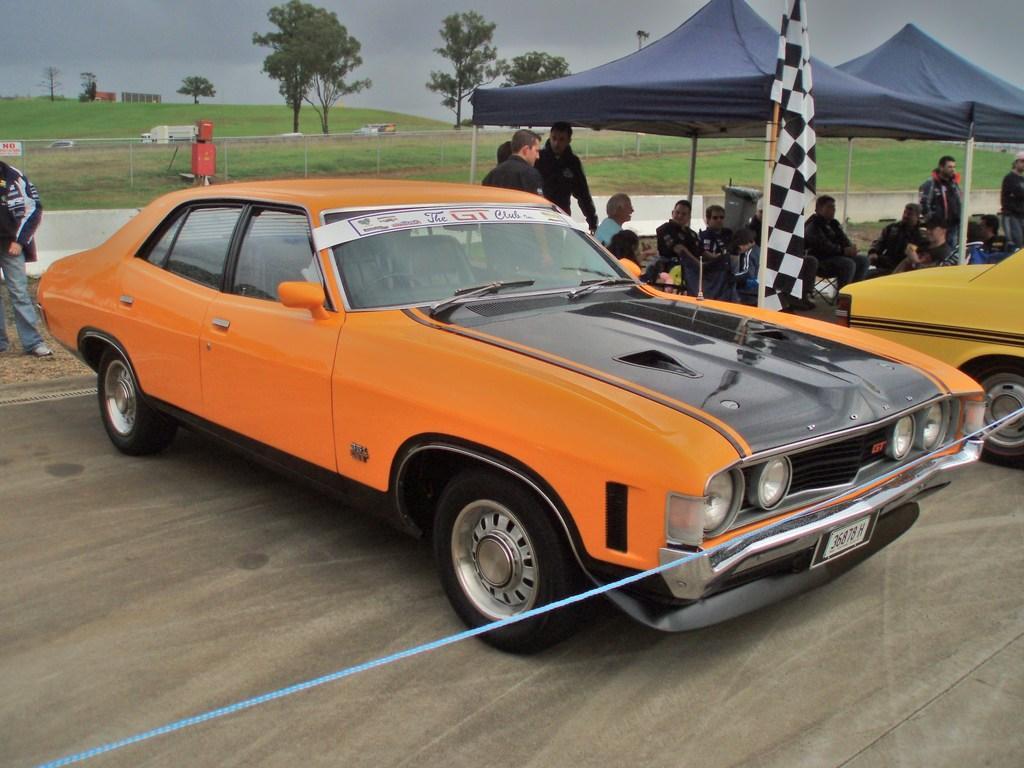How would you summarize this image in a sentence or two? This image is taken outdoors. At the bottom of the image there is a road. At the top of the image there is a sky with clouds. In the middle of the image two cars are parked on the road. A few people are sitting under the tents and a few are standing. There is a flag. In the background there are a few trees and there is a fence. A few vehicles are moving on the road. On the left side of the image a man is standing on the ground. 